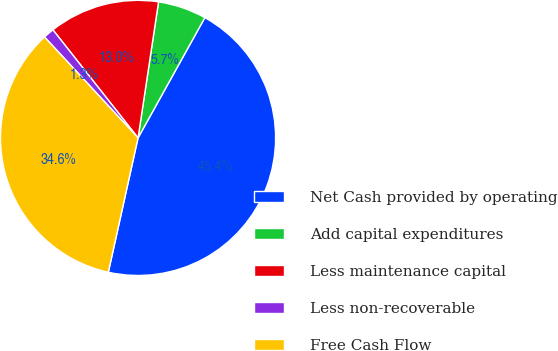<chart> <loc_0><loc_0><loc_500><loc_500><pie_chart><fcel>Net Cash provided by operating<fcel>Add capital expenditures<fcel>Less maintenance capital<fcel>Less non-recoverable<fcel>Free Cash Flow<nl><fcel>45.4%<fcel>5.69%<fcel>13.0%<fcel>1.28%<fcel>34.64%<nl></chart> 